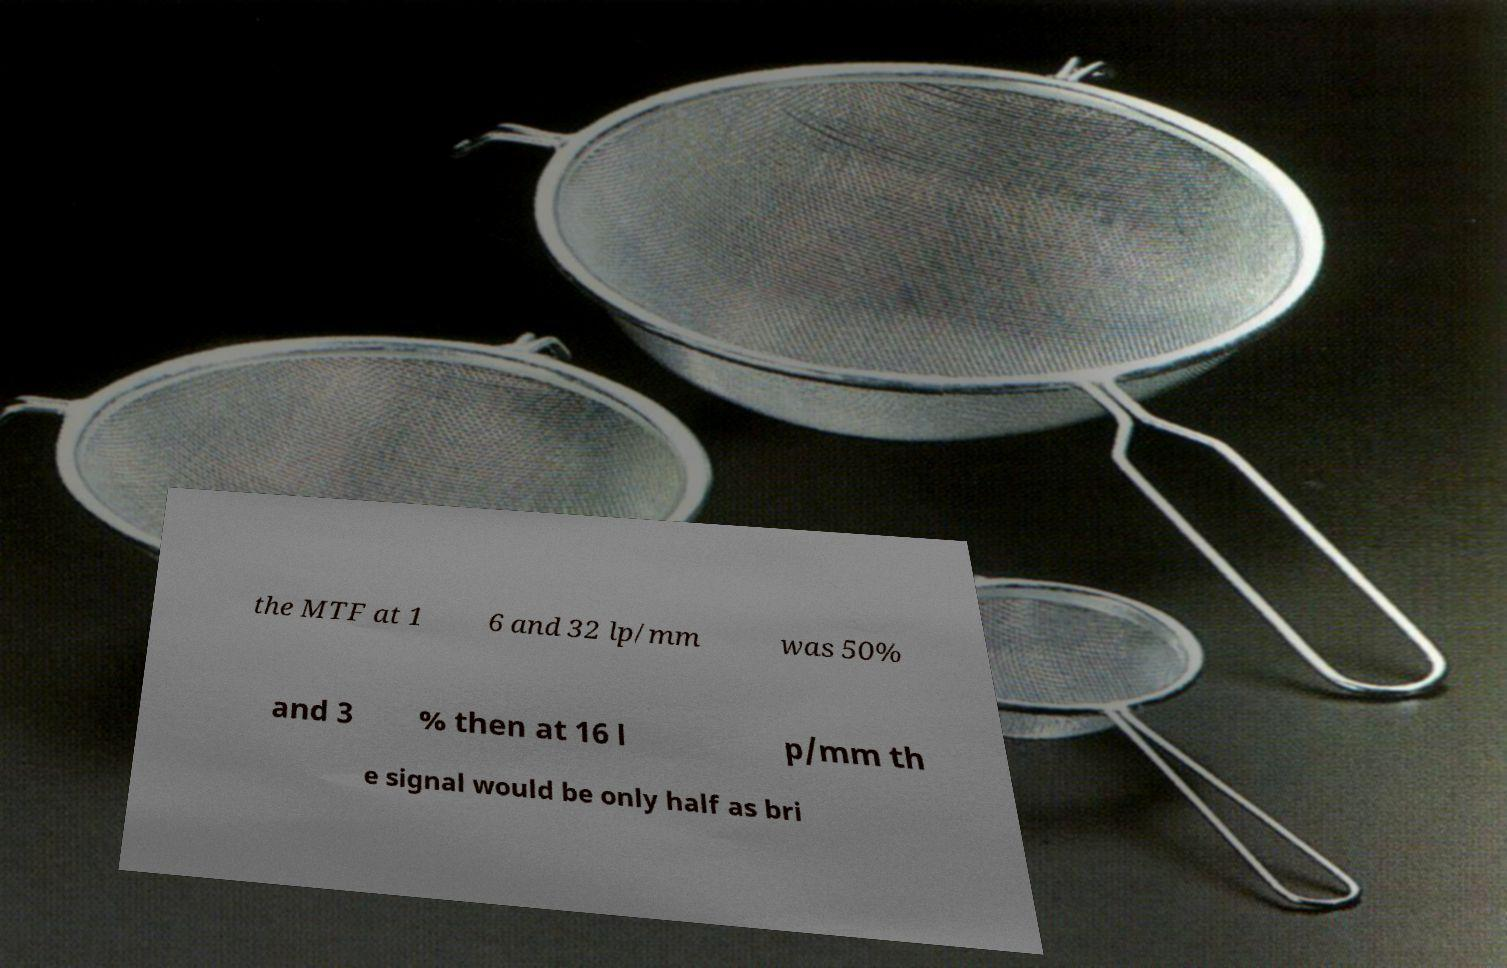I need the written content from this picture converted into text. Can you do that? the MTF at 1 6 and 32 lp/mm was 50% and 3 % then at 16 l p/mm th e signal would be only half as bri 